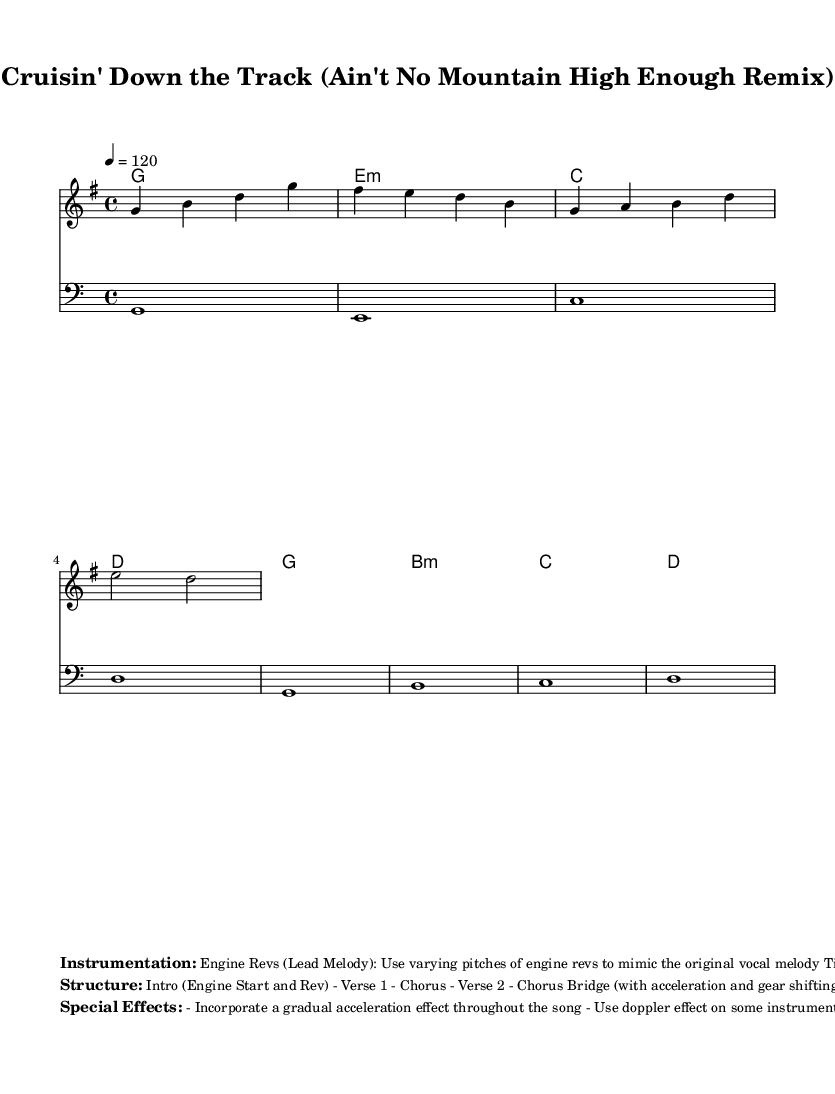What is the key signature of this music? The key signature is G major, indicated by one sharp (#) on the F line.
Answer: G major What is the time signature of this music? The time signature is 4/4, shown at the beginning of the score with the '4' over '4'.
Answer: 4/4 What is the tempo marking for this piece? The tempo marking is 120 beats per minute, which is indicated in the score.
Answer: 120 How many sections are there in the structure of the music? The provided structure includes six sections: Intro, Verse 1, Chorus, Verse 2, Chorus, Bridge, Chorus, and Outro. Counting these reveals it has a total of six sections.
Answer: Six What type of instruments are used for the lead melody? The lead melody uses engine revs to mimic the vocal melody, as specified in the instrumentation section.
Answer: Engine Revs Which special effect is noted for use in the transitional sections? Gear shifting sounds are indicated as a special effect between sections to enhance transitions.
Answer: Gear shifting sounds 